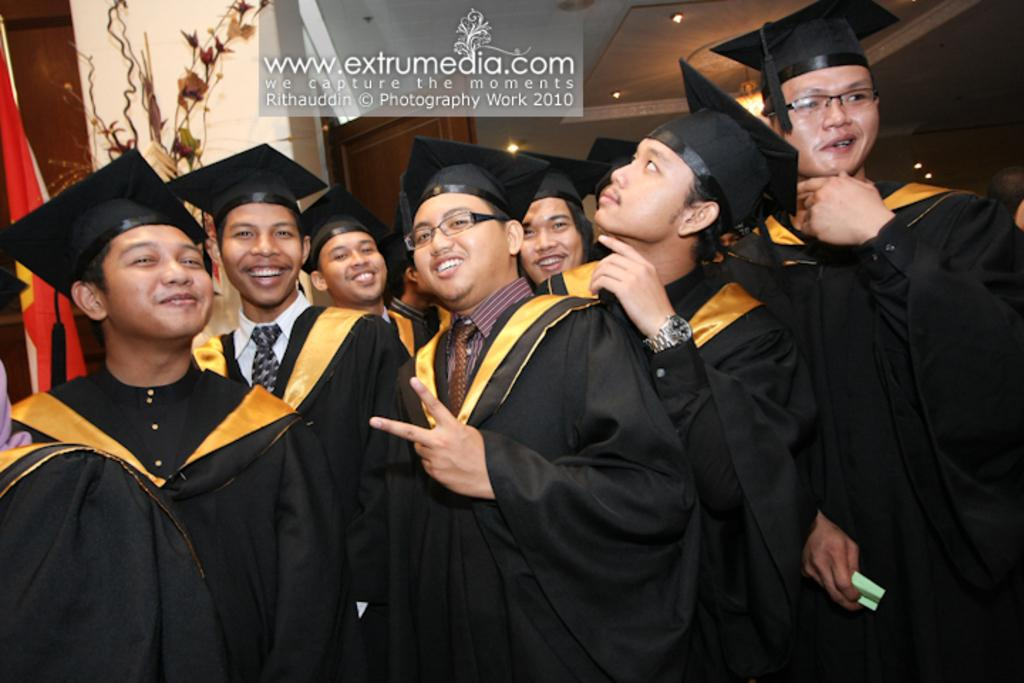Who or what is present in the image? There are people in the image. What are the people wearing? The people are wearing graduation dress. Can you describe any text visible in the image? There is some text visible at the top of the image. How does the picture compare to a painting of a landscape? The image is not a painting of a landscape; it is a photograph of people wearing graduation dress. 